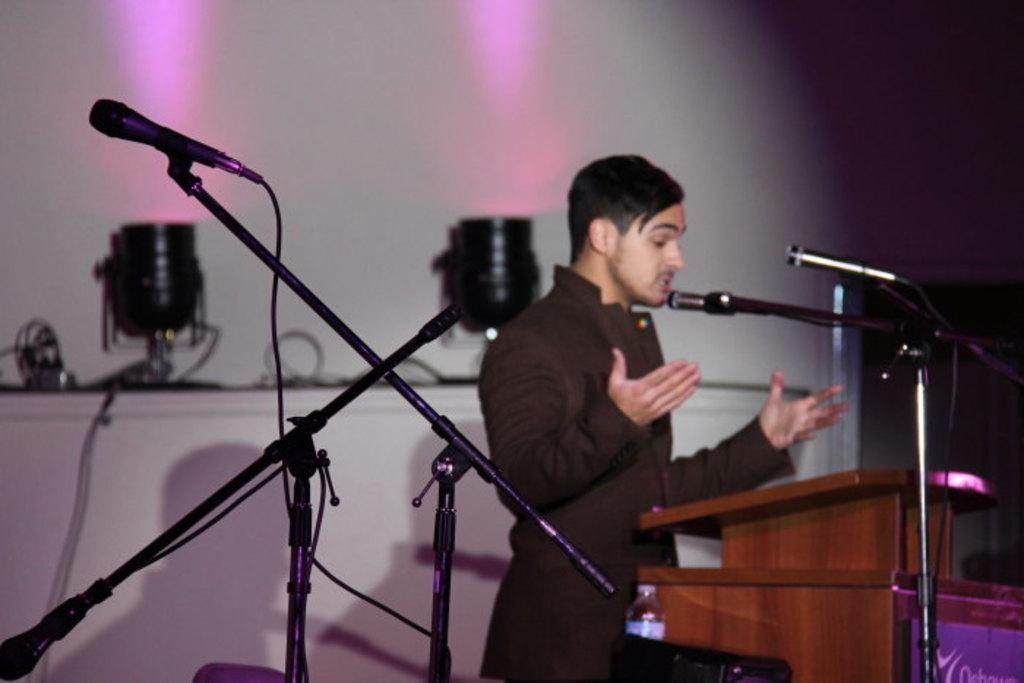In one or two sentences, can you explain what this image depicts? In this picture there is a boy wearing black shirt and pant is singing in the microphone. In the front bottom side there is a brown color speech desk. On the left side there are two microphone. In the background we can see two black color spotlight and white wall. 